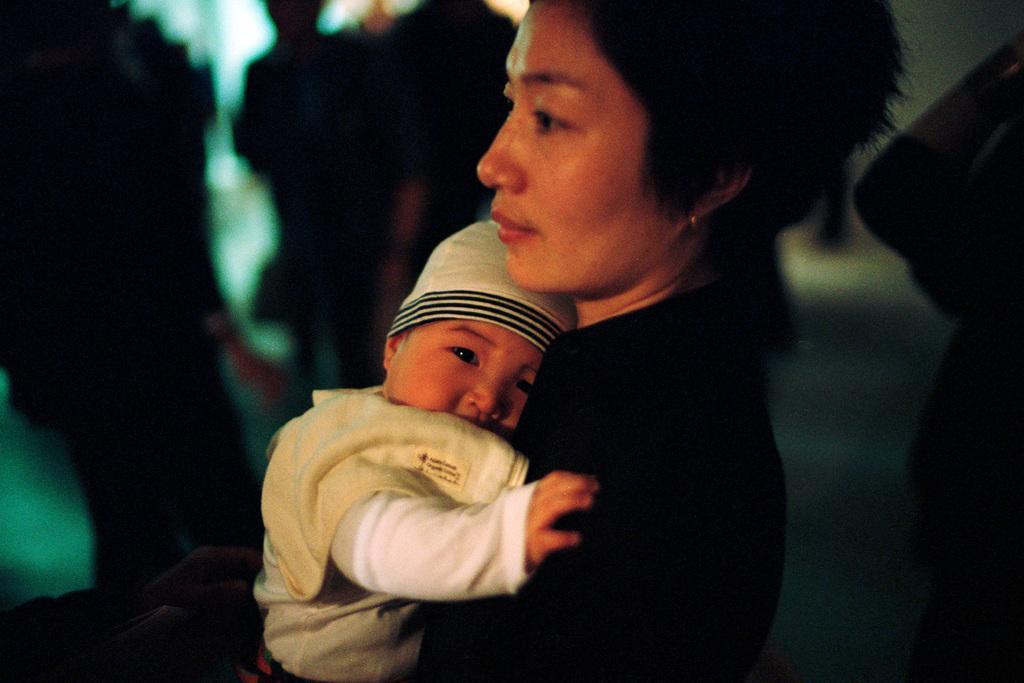Can you describe this image briefly? In this picture there is a lady and a small baby in her hands in the image and there are other people in the background area of the image. 